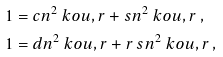<formula> <loc_0><loc_0><loc_500><loc_500>1 & = c n ^ { 2 } \ k o { u , r } + s n ^ { 2 } \ k o { u , r } \, , \\ 1 & = d n ^ { 2 } \ k o { u , r } + r \, s n ^ { 2 } \ k o { u , r } \, ,</formula> 